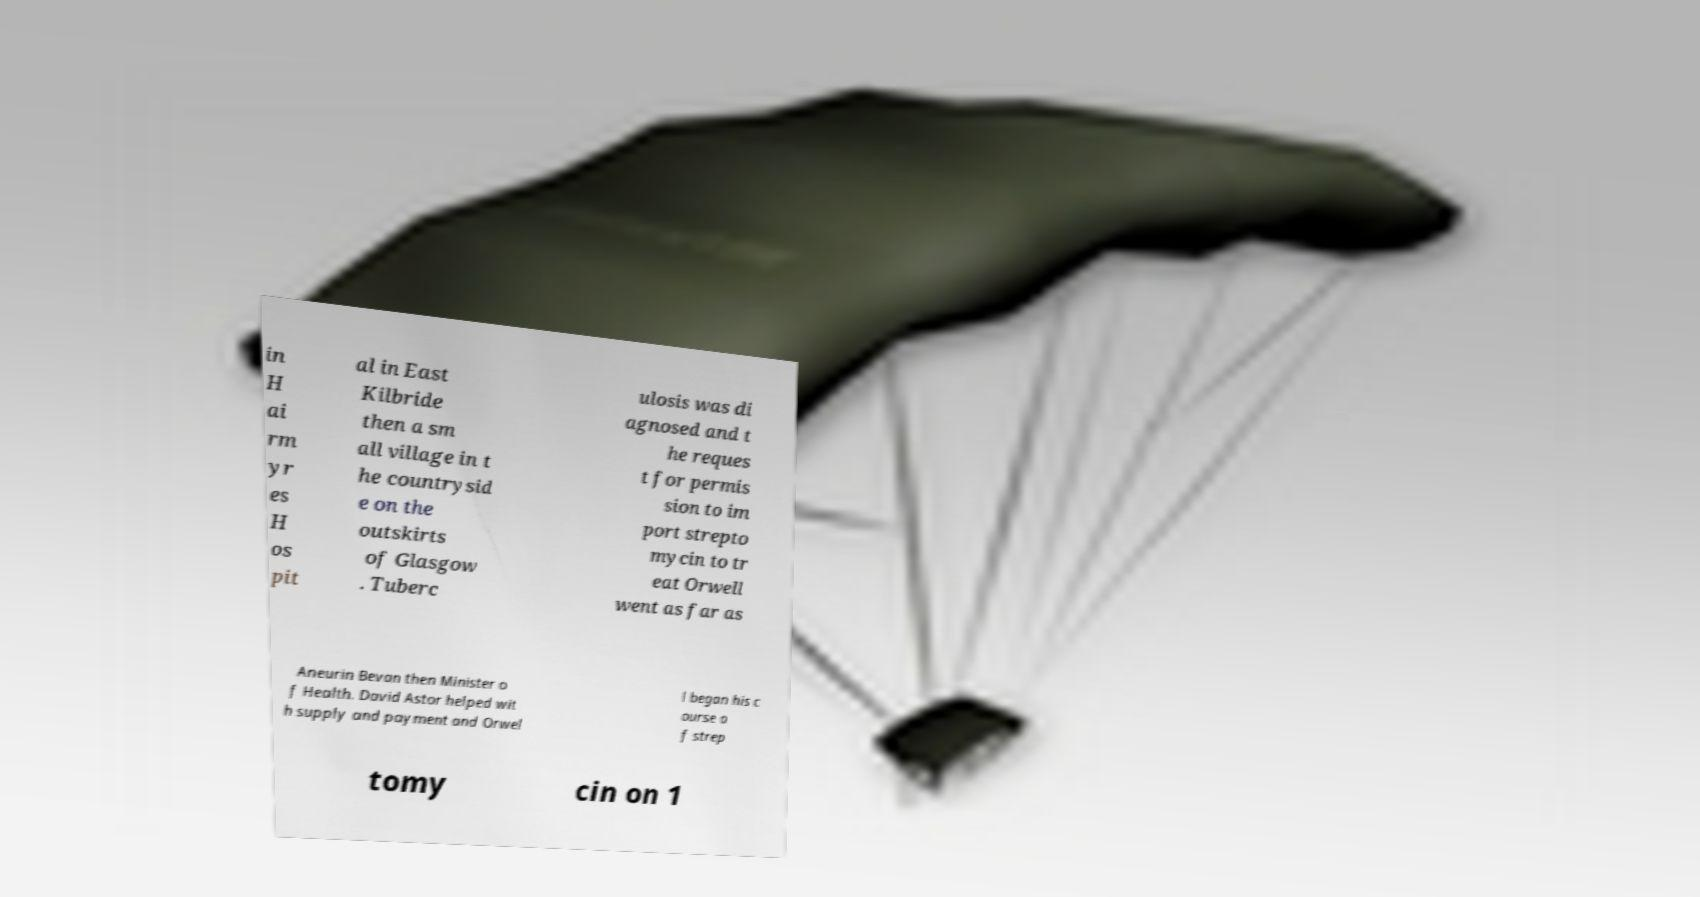Please identify and transcribe the text found in this image. in H ai rm yr es H os pit al in East Kilbride then a sm all village in t he countrysid e on the outskirts of Glasgow . Tuberc ulosis was di agnosed and t he reques t for permis sion to im port strepto mycin to tr eat Orwell went as far as Aneurin Bevan then Minister o f Health. David Astor helped wit h supply and payment and Orwel l began his c ourse o f strep tomy cin on 1 